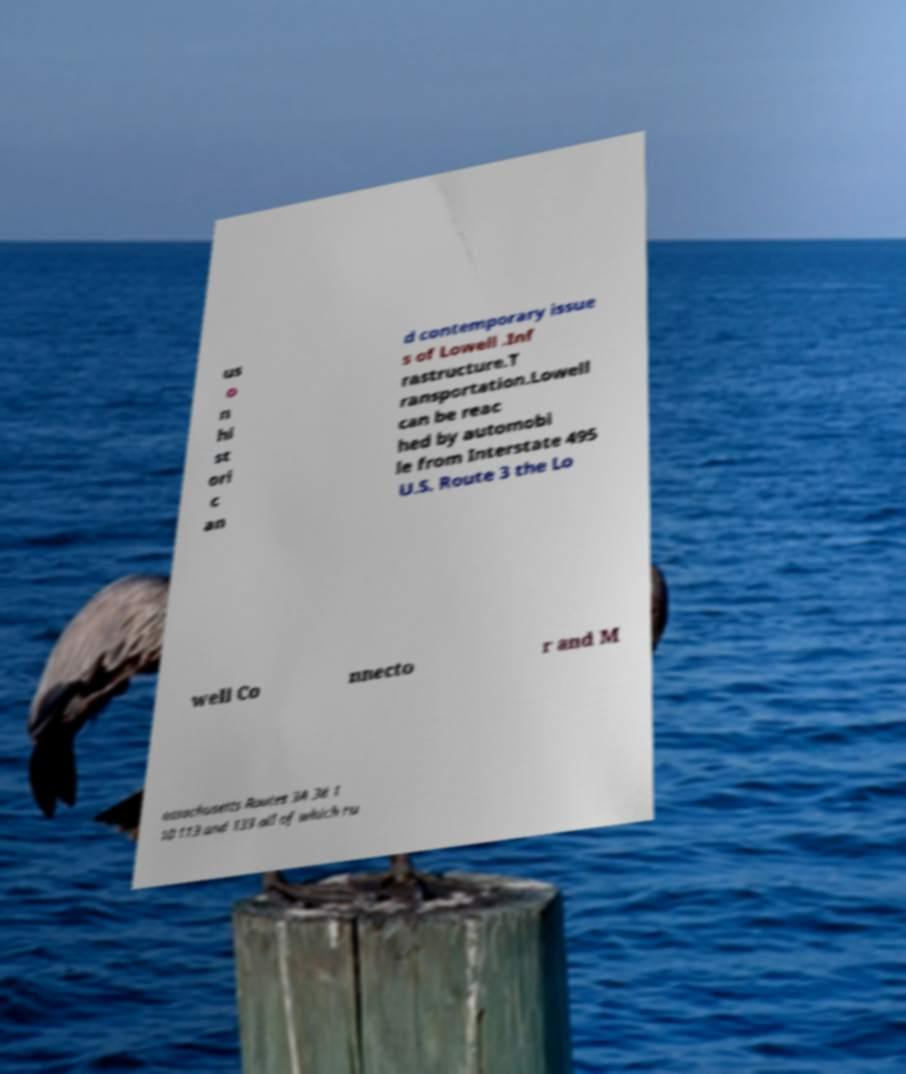Could you assist in decoding the text presented in this image and type it out clearly? us o n hi st ori c an d contemporary issue s of Lowell .Inf rastructure.T ransportation.Lowell can be reac hed by automobi le from Interstate 495 U.S. Route 3 the Lo well Co nnecto r and M assachusetts Routes 3A 38 1 10 113 and 133 all of which ru 